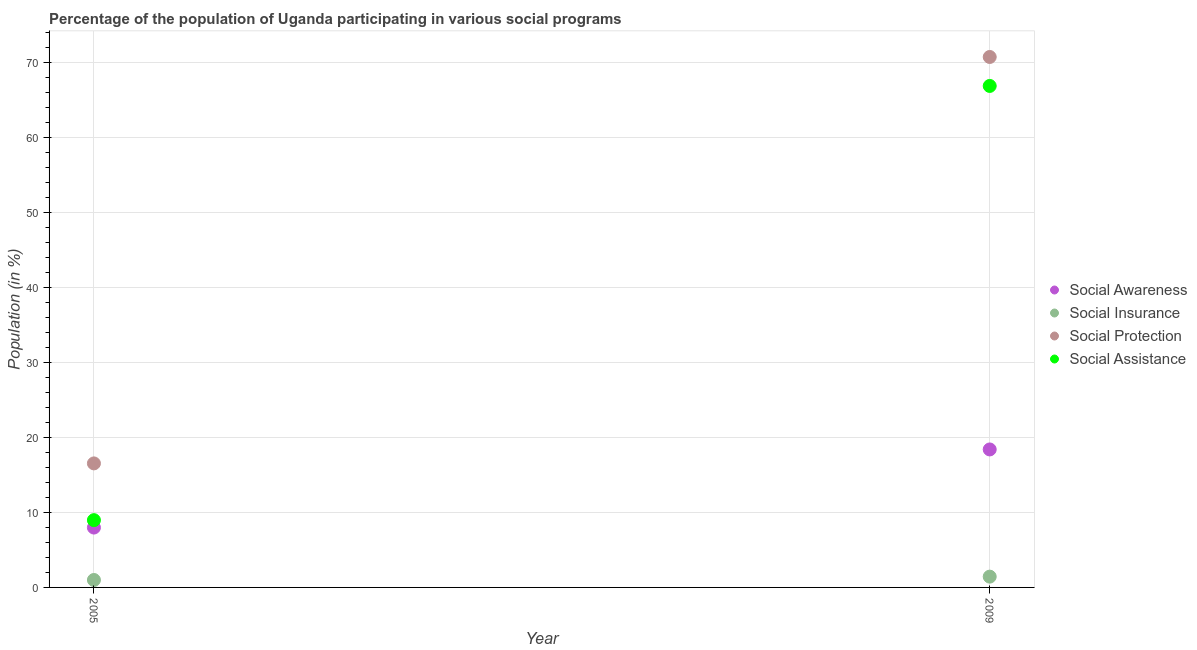How many different coloured dotlines are there?
Your answer should be compact. 4. Is the number of dotlines equal to the number of legend labels?
Ensure brevity in your answer.  Yes. What is the participation of population in social insurance programs in 2005?
Your answer should be compact. 0.99. Across all years, what is the maximum participation of population in social insurance programs?
Your response must be concise. 1.44. Across all years, what is the minimum participation of population in social awareness programs?
Provide a succinct answer. 7.98. In which year was the participation of population in social awareness programs maximum?
Ensure brevity in your answer.  2009. In which year was the participation of population in social awareness programs minimum?
Provide a succinct answer. 2005. What is the total participation of population in social assistance programs in the graph?
Provide a succinct answer. 75.8. What is the difference between the participation of population in social insurance programs in 2005 and that in 2009?
Make the answer very short. -0.45. What is the difference between the participation of population in social assistance programs in 2009 and the participation of population in social insurance programs in 2005?
Offer a very short reply. 65.84. What is the average participation of population in social awareness programs per year?
Offer a very short reply. 13.18. In the year 2009, what is the difference between the participation of population in social awareness programs and participation of population in social protection programs?
Your answer should be very brief. -52.3. In how many years, is the participation of population in social protection programs greater than 8 %?
Keep it short and to the point. 2. What is the ratio of the participation of population in social assistance programs in 2005 to that in 2009?
Provide a succinct answer. 0.13. Is the participation of population in social protection programs in 2005 less than that in 2009?
Make the answer very short. Yes. Is it the case that in every year, the sum of the participation of population in social insurance programs and participation of population in social awareness programs is greater than the sum of participation of population in social protection programs and participation of population in social assistance programs?
Keep it short and to the point. Yes. What is the difference between two consecutive major ticks on the Y-axis?
Offer a very short reply. 10. Where does the legend appear in the graph?
Provide a short and direct response. Center right. What is the title of the graph?
Provide a short and direct response. Percentage of the population of Uganda participating in various social programs . Does "Labor Taxes" appear as one of the legend labels in the graph?
Give a very brief answer. No. What is the label or title of the Y-axis?
Keep it short and to the point. Population (in %). What is the Population (in %) of Social Awareness in 2005?
Keep it short and to the point. 7.98. What is the Population (in %) in Social Insurance in 2005?
Ensure brevity in your answer.  0.99. What is the Population (in %) of Social Protection in 2005?
Keep it short and to the point. 16.53. What is the Population (in %) in Social Assistance in 2005?
Offer a very short reply. 8.97. What is the Population (in %) of Social Awareness in 2009?
Your response must be concise. 18.39. What is the Population (in %) of Social Insurance in 2009?
Provide a short and direct response. 1.44. What is the Population (in %) in Social Protection in 2009?
Your response must be concise. 70.69. What is the Population (in %) of Social Assistance in 2009?
Give a very brief answer. 66.83. Across all years, what is the maximum Population (in %) in Social Awareness?
Make the answer very short. 18.39. Across all years, what is the maximum Population (in %) of Social Insurance?
Your answer should be compact. 1.44. Across all years, what is the maximum Population (in %) in Social Protection?
Make the answer very short. 70.69. Across all years, what is the maximum Population (in %) in Social Assistance?
Provide a short and direct response. 66.83. Across all years, what is the minimum Population (in %) in Social Awareness?
Offer a very short reply. 7.98. Across all years, what is the minimum Population (in %) of Social Insurance?
Make the answer very short. 0.99. Across all years, what is the minimum Population (in %) in Social Protection?
Offer a terse response. 16.53. Across all years, what is the minimum Population (in %) in Social Assistance?
Your answer should be very brief. 8.97. What is the total Population (in %) in Social Awareness in the graph?
Your answer should be compact. 26.36. What is the total Population (in %) of Social Insurance in the graph?
Your answer should be very brief. 2.43. What is the total Population (in %) in Social Protection in the graph?
Give a very brief answer. 87.22. What is the total Population (in %) of Social Assistance in the graph?
Your answer should be compact. 75.8. What is the difference between the Population (in %) of Social Awareness in 2005 and that in 2009?
Keep it short and to the point. -10.41. What is the difference between the Population (in %) in Social Insurance in 2005 and that in 2009?
Give a very brief answer. -0.45. What is the difference between the Population (in %) of Social Protection in 2005 and that in 2009?
Your answer should be compact. -54.16. What is the difference between the Population (in %) of Social Assistance in 2005 and that in 2009?
Keep it short and to the point. -57.86. What is the difference between the Population (in %) in Social Awareness in 2005 and the Population (in %) in Social Insurance in 2009?
Your answer should be compact. 6.54. What is the difference between the Population (in %) in Social Awareness in 2005 and the Population (in %) in Social Protection in 2009?
Keep it short and to the point. -62.71. What is the difference between the Population (in %) of Social Awareness in 2005 and the Population (in %) of Social Assistance in 2009?
Provide a short and direct response. -58.85. What is the difference between the Population (in %) of Social Insurance in 2005 and the Population (in %) of Social Protection in 2009?
Keep it short and to the point. -69.7. What is the difference between the Population (in %) in Social Insurance in 2005 and the Population (in %) in Social Assistance in 2009?
Offer a very short reply. -65.84. What is the difference between the Population (in %) of Social Protection in 2005 and the Population (in %) of Social Assistance in 2009?
Give a very brief answer. -50.3. What is the average Population (in %) of Social Awareness per year?
Provide a short and direct response. 13.18. What is the average Population (in %) in Social Insurance per year?
Provide a short and direct response. 1.21. What is the average Population (in %) of Social Protection per year?
Provide a short and direct response. 43.61. What is the average Population (in %) in Social Assistance per year?
Your response must be concise. 37.9. In the year 2005, what is the difference between the Population (in %) in Social Awareness and Population (in %) in Social Insurance?
Offer a terse response. 6.99. In the year 2005, what is the difference between the Population (in %) of Social Awareness and Population (in %) of Social Protection?
Offer a terse response. -8.55. In the year 2005, what is the difference between the Population (in %) in Social Awareness and Population (in %) in Social Assistance?
Offer a very short reply. -0.99. In the year 2005, what is the difference between the Population (in %) in Social Insurance and Population (in %) in Social Protection?
Your answer should be very brief. -15.54. In the year 2005, what is the difference between the Population (in %) in Social Insurance and Population (in %) in Social Assistance?
Your answer should be compact. -7.98. In the year 2005, what is the difference between the Population (in %) in Social Protection and Population (in %) in Social Assistance?
Ensure brevity in your answer.  7.56. In the year 2009, what is the difference between the Population (in %) in Social Awareness and Population (in %) in Social Insurance?
Provide a succinct answer. 16.95. In the year 2009, what is the difference between the Population (in %) in Social Awareness and Population (in %) in Social Protection?
Keep it short and to the point. -52.3. In the year 2009, what is the difference between the Population (in %) in Social Awareness and Population (in %) in Social Assistance?
Offer a very short reply. -48.44. In the year 2009, what is the difference between the Population (in %) in Social Insurance and Population (in %) in Social Protection?
Ensure brevity in your answer.  -69.25. In the year 2009, what is the difference between the Population (in %) of Social Insurance and Population (in %) of Social Assistance?
Give a very brief answer. -65.39. In the year 2009, what is the difference between the Population (in %) in Social Protection and Population (in %) in Social Assistance?
Your response must be concise. 3.86. What is the ratio of the Population (in %) in Social Awareness in 2005 to that in 2009?
Give a very brief answer. 0.43. What is the ratio of the Population (in %) of Social Insurance in 2005 to that in 2009?
Offer a very short reply. 0.69. What is the ratio of the Population (in %) of Social Protection in 2005 to that in 2009?
Make the answer very short. 0.23. What is the ratio of the Population (in %) of Social Assistance in 2005 to that in 2009?
Offer a very short reply. 0.13. What is the difference between the highest and the second highest Population (in %) in Social Awareness?
Keep it short and to the point. 10.41. What is the difference between the highest and the second highest Population (in %) in Social Insurance?
Keep it short and to the point. 0.45. What is the difference between the highest and the second highest Population (in %) of Social Protection?
Give a very brief answer. 54.16. What is the difference between the highest and the second highest Population (in %) in Social Assistance?
Provide a succinct answer. 57.86. What is the difference between the highest and the lowest Population (in %) in Social Awareness?
Your answer should be very brief. 10.41. What is the difference between the highest and the lowest Population (in %) in Social Insurance?
Offer a very short reply. 0.45. What is the difference between the highest and the lowest Population (in %) in Social Protection?
Ensure brevity in your answer.  54.16. What is the difference between the highest and the lowest Population (in %) in Social Assistance?
Your answer should be compact. 57.86. 